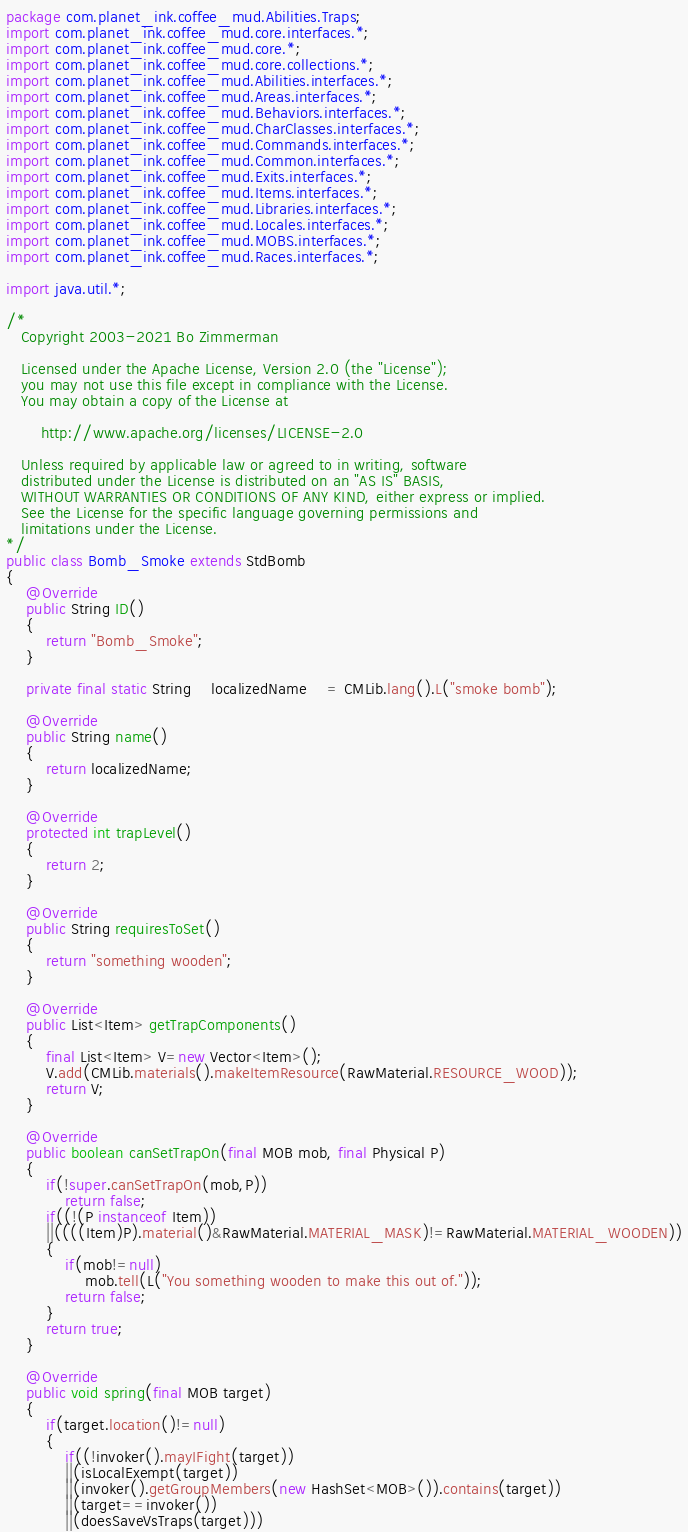Convert code to text. <code><loc_0><loc_0><loc_500><loc_500><_Java_>package com.planet_ink.coffee_mud.Abilities.Traps;
import com.planet_ink.coffee_mud.core.interfaces.*;
import com.planet_ink.coffee_mud.core.*;
import com.planet_ink.coffee_mud.core.collections.*;
import com.planet_ink.coffee_mud.Abilities.interfaces.*;
import com.planet_ink.coffee_mud.Areas.interfaces.*;
import com.planet_ink.coffee_mud.Behaviors.interfaces.*;
import com.planet_ink.coffee_mud.CharClasses.interfaces.*;
import com.planet_ink.coffee_mud.Commands.interfaces.*;
import com.planet_ink.coffee_mud.Common.interfaces.*;
import com.planet_ink.coffee_mud.Exits.interfaces.*;
import com.planet_ink.coffee_mud.Items.interfaces.*;
import com.planet_ink.coffee_mud.Libraries.interfaces.*;
import com.planet_ink.coffee_mud.Locales.interfaces.*;
import com.planet_ink.coffee_mud.MOBS.interfaces.*;
import com.planet_ink.coffee_mud.Races.interfaces.*;

import java.util.*;

/*
   Copyright 2003-2021 Bo Zimmerman

   Licensed under the Apache License, Version 2.0 (the "License");
   you may not use this file except in compliance with the License.
   You may obtain a copy of the License at

	   http://www.apache.org/licenses/LICENSE-2.0

   Unless required by applicable law or agreed to in writing, software
   distributed under the License is distributed on an "AS IS" BASIS,
   WITHOUT WARRANTIES OR CONDITIONS OF ANY KIND, either express or implied.
   See the License for the specific language governing permissions and
   limitations under the License.
*/
public class Bomb_Smoke extends StdBomb
{
	@Override
	public String ID()
	{
		return "Bomb_Smoke";
	}

	private final static String	localizedName	= CMLib.lang().L("smoke bomb");

	@Override
	public String name()
	{
		return localizedName;
	}

	@Override
	protected int trapLevel()
	{
		return 2;
	}

	@Override
	public String requiresToSet()
	{
		return "something wooden";
	}

	@Override
	public List<Item> getTrapComponents()
	{
		final List<Item> V=new Vector<Item>();
		V.add(CMLib.materials().makeItemResource(RawMaterial.RESOURCE_WOOD));
		return V;
	}

	@Override
	public boolean canSetTrapOn(final MOB mob, final Physical P)
	{
		if(!super.canSetTrapOn(mob,P))
			return false;
		if((!(P instanceof Item))
		||((((Item)P).material()&RawMaterial.MATERIAL_MASK)!=RawMaterial.MATERIAL_WOODEN))
		{
			if(mob!=null)
				mob.tell(L("You something wooden to make this out of."));
			return false;
		}
		return true;
	}

	@Override
	public void spring(final MOB target)
	{
		if(target.location()!=null)
		{
			if((!invoker().mayIFight(target))
			||(isLocalExempt(target))
			||(invoker().getGroupMembers(new HashSet<MOB>()).contains(target))
			||(target==invoker())
			||(doesSaveVsTraps(target)))</code> 